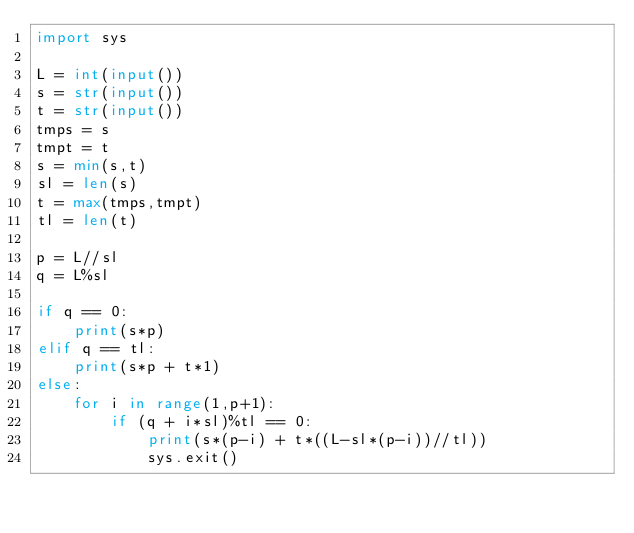<code> <loc_0><loc_0><loc_500><loc_500><_Python_>import sys

L = int(input())
s = str(input())
t = str(input())
tmps = s
tmpt = t
s = min(s,t)
sl = len(s)
t = max(tmps,tmpt)
tl = len(t)

p = L//sl
q = L%sl

if q == 0:
    print(s*p)
elif q == tl:
    print(s*p + t*1)
else:
    for i in range(1,p+1):
        if (q + i*sl)%tl == 0:
            print(s*(p-i) + t*((L-sl*(p-i))//tl))
            sys.exit()


</code> 